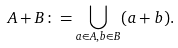Convert formula to latex. <formula><loc_0><loc_0><loc_500><loc_500>A + B \colon = \bigcup _ { a \in A , b \in B } ( a + b ) .</formula> 